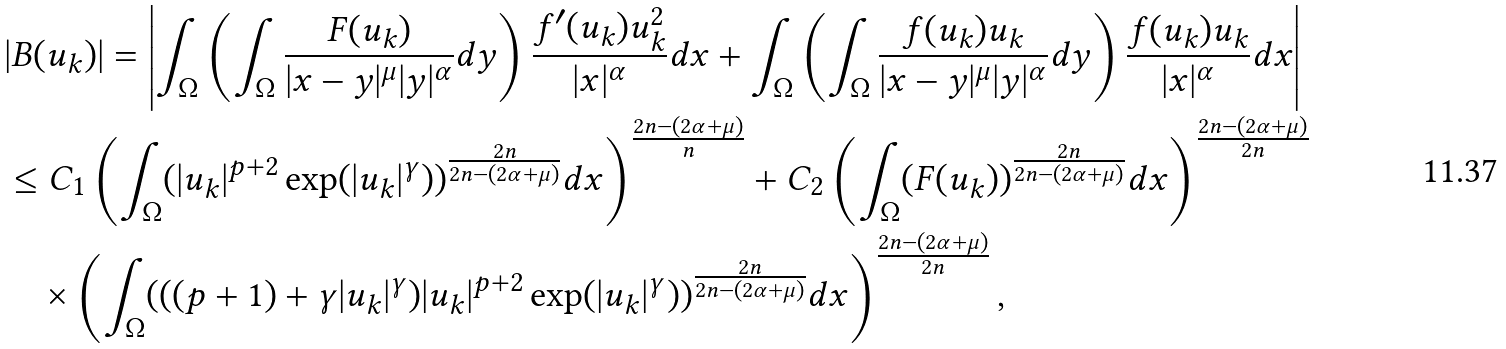<formula> <loc_0><loc_0><loc_500><loc_500>& | B ( u _ { k } ) | = \left | \int _ { \Omega } \left ( \int _ { \Omega } \frac { F ( u _ { k } ) } { | x - y | ^ { \mu } | y | ^ { \alpha } } d y \right ) \frac { f ^ { \prime } ( u _ { k } ) u _ { k } ^ { 2 } } { | x | ^ { \alpha } } d x + \int _ { \Omega } \left ( \int _ { \Omega } \frac { f ( u _ { k } ) u _ { k } } { | x - y | ^ { \mu } | y | ^ { \alpha } } d y \right ) \frac { f ( u _ { k } ) u _ { k } } { | x | ^ { \alpha } } d x \right | \\ & \leq C _ { 1 } \left ( \int _ { \Omega } ( | u _ { k } | ^ { p + 2 } \exp ( | u _ { k } | ^ { \gamma } ) ) ^ { \frac { 2 n } { 2 n - ( 2 \alpha + \mu ) } } d x \right ) ^ { \frac { 2 n - ( 2 \alpha + \mu ) } { n } } + C _ { 2 } \left ( \int _ { \Omega } ( F ( u _ { k } ) ) ^ { \frac { 2 n } { 2 n - ( 2 \alpha + \mu ) } } d x \right ) ^ { \frac { 2 n - ( 2 \alpha + \mu ) } { 2 n } } \\ & \quad \times \left ( \int _ { \Omega } ( ( ( p + 1 ) + \gamma | u _ { k } | ^ { \gamma } ) | u _ { k } | ^ { p + 2 } \exp ( | u _ { k } | ^ { \gamma } ) ) ^ { \frac { 2 n } { 2 n - ( 2 \alpha + \mu ) } } d x \right ) ^ { \frac { 2 n - ( 2 \alpha + \mu ) } { 2 n } } ,</formula> 